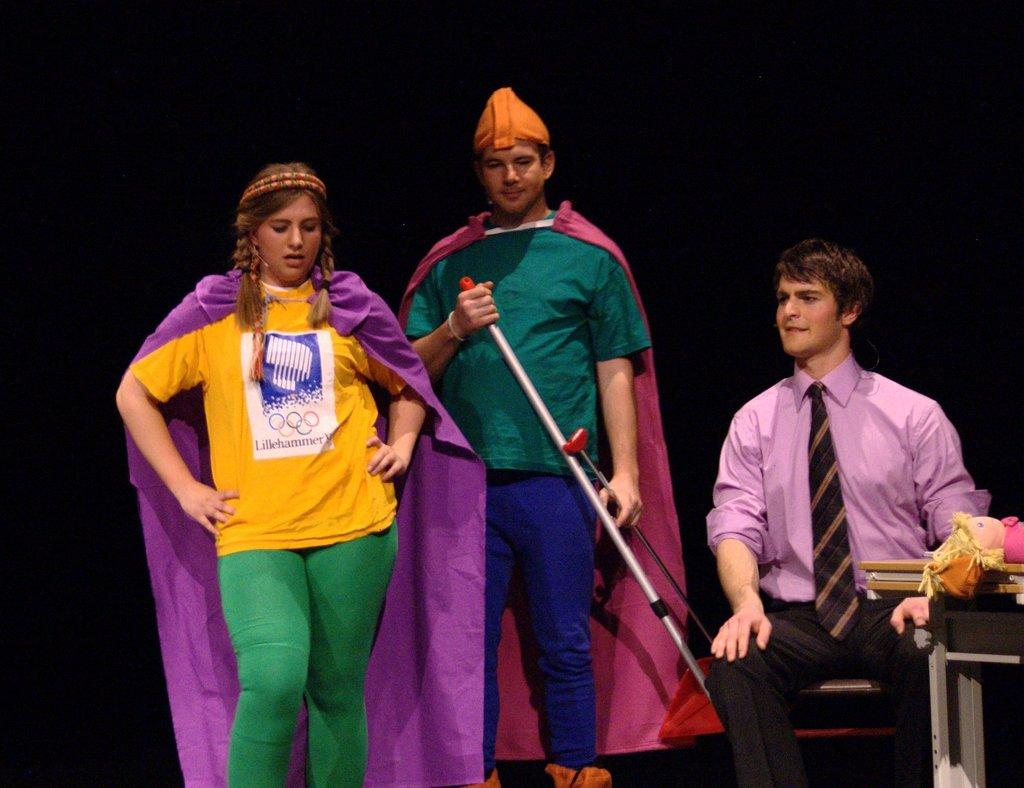What is the man in the image doing? The man is sitting on a chair in the image. How many people are standing in the image? There are two people standing in the image. What object can be seen on a table in the image? There is a toy on a table in the image. What can be observed about the background of the image? The background of the image is dark. What number is the man rewarding himself with in the image? There is no indication in the image that the man is rewarding himself with a number. What type of self-reflection can be seen in the image? There is no self-reflection present in the image; it features a man sitting on a chair, two people standing, a toy on a table, and a dark background. 